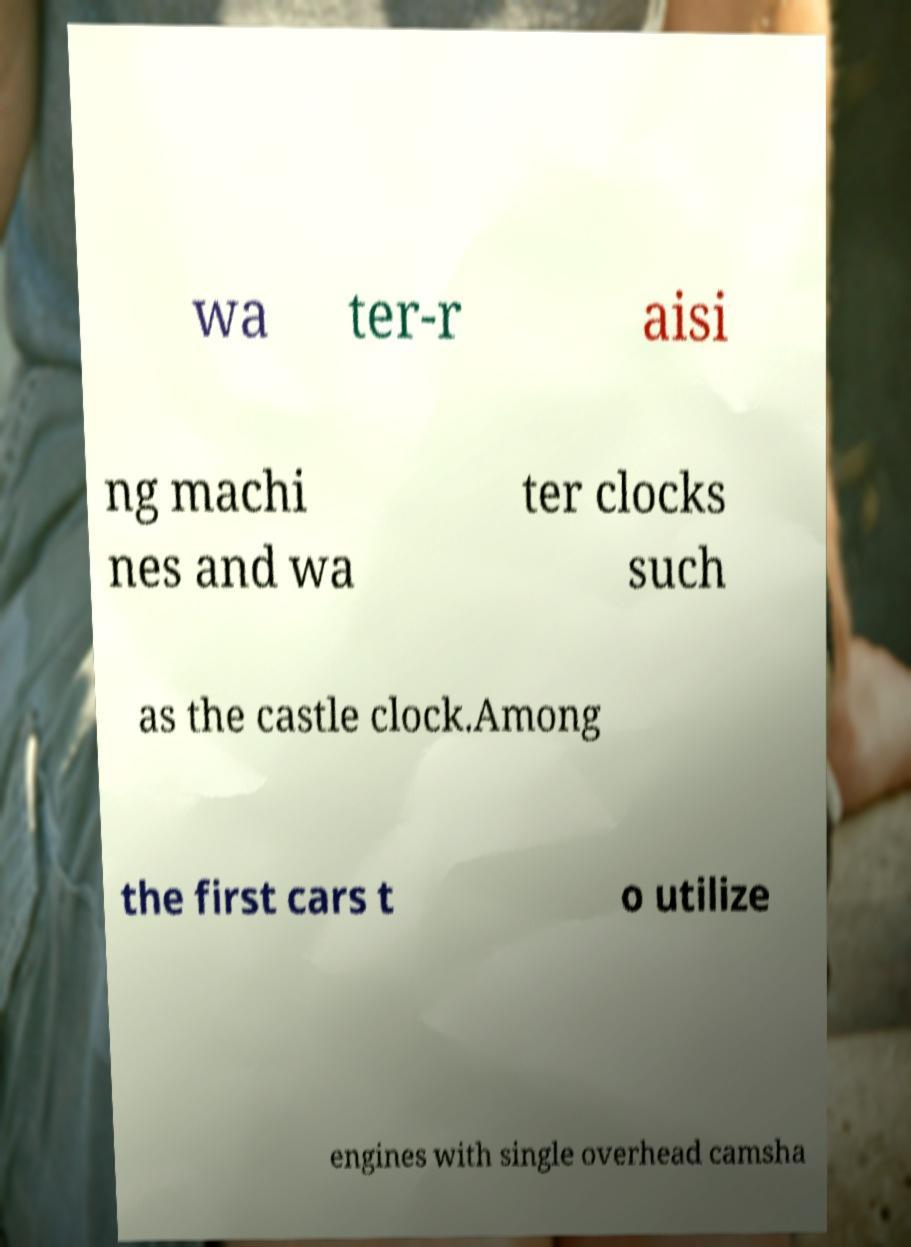There's text embedded in this image that I need extracted. Can you transcribe it verbatim? wa ter-r aisi ng machi nes and wa ter clocks such as the castle clock.Among the first cars t o utilize engines with single overhead camsha 